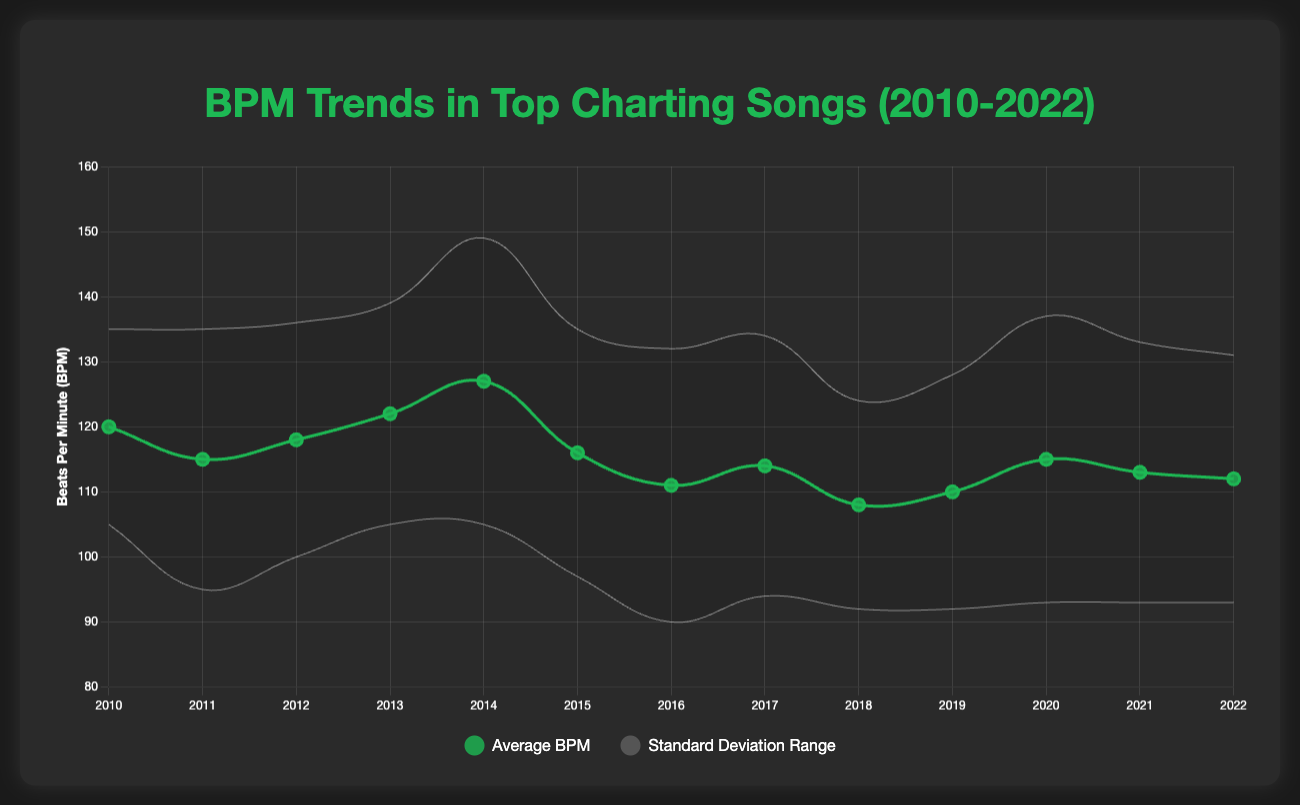What is the overall trend in the average BPM of top charting songs from 2010 to 2022? The trend can be observed by looking at the line representing the "Average BPM" on the chart. From 2010 to 2014, there is a gradual increase in the average BPM, peaking in 2014. After 2014, there's a noticeable decline until 2018, with a slight increase in 2019 and 2020, followed by another slight decline up to 2022.
Answer: Increasing until 2014, then decreasing with slight fluctuations Which year had the highest average BPM, and what was it? By inspecting the peak of the "Average BPM" line, we can see that 2014 had the highest average BPM. The chart indicates that the average BPM in 2014 was around 127.
Answer: 2014, 127 BPM Is there a notable year where the standard deviation range (indicated by the shaded area) is significantly larger than other years? The shaded area between the “Upper Bound” and “Lower Bound” lines represents the standard deviation range. By evaluating the width of this area, we observe that 2014 has a notably larger standard deviation compared to other years, indicating more variability in BPM.
Answer: 2014 In which year did the average BPM experience the largest decrease compared to the previous year? To find the largest decrease, compare the change in average BPM between consecutive years. The drop from 127 BPM in 2014 to 116 BPM in 2015 reflects the largest decrease (127 - 116 = 11 BPM).
Answer: 2015 What is the approximate BPM range for the year 2020 based on the standard deviation? The range can be calculated by adding and subtracting the standard deviation from the average BPM. For 2020, the average BPM is 115, and the standard deviation is 22. Thus, the range is 115 - 22 to 115 + 22, which is approximately 93 BPM to 137 BPM.
Answer: 93 to 137 BPM Compare the average BPM in 2012 to that in 2016. Which year had a higher average BPM and by how much? By comparing the two years, the average BPM in 2012 is 118, and in 2016 it is 111. To determine the difference, we subtract 111 from 118.
Answer: 2012, by 7 BPM How does the average BPM in 2018 compare to the average BPM in 2022? Check the average BPM for both years: 108 BPM in 2018 and 112 BPM in 2022. This indicates that there was an increase of 4 BPM from 2018 to 2022.
Answer: 2022 is higher by 4 BPM Which year had the lowest average BPM, and what was it? Observing the lowest point on the "Average BPM" line, 2018 had the lowest average BPM with a value of approximately 108 BPM.
Answer: 2018, 108 BPM What is the difference in the standard deviation between the years 2011 and 2019? By examining the standard deviation values, we find that in 2011 it was 20, and in 2019 it was 18. The difference is calculated by subtracting the smaller value from the greater one (20 - 18).
Answer: 2 BPM What can you infer about the musical tempo preference of top charting songs from 2010 to 2022 based on the chart? The chart shows that musical preferences in terms of BPM have fluctuated. Initially, there was an increase in average BPM, peaking in 2014, suggesting a preference for faster tempos. This was followed by a decline, indicating a shift to slower tempos. The slight increases and decreases in the latter years reflect varying trends in tempo preference.
Answer: Varying tempo preference with peaks and declines 